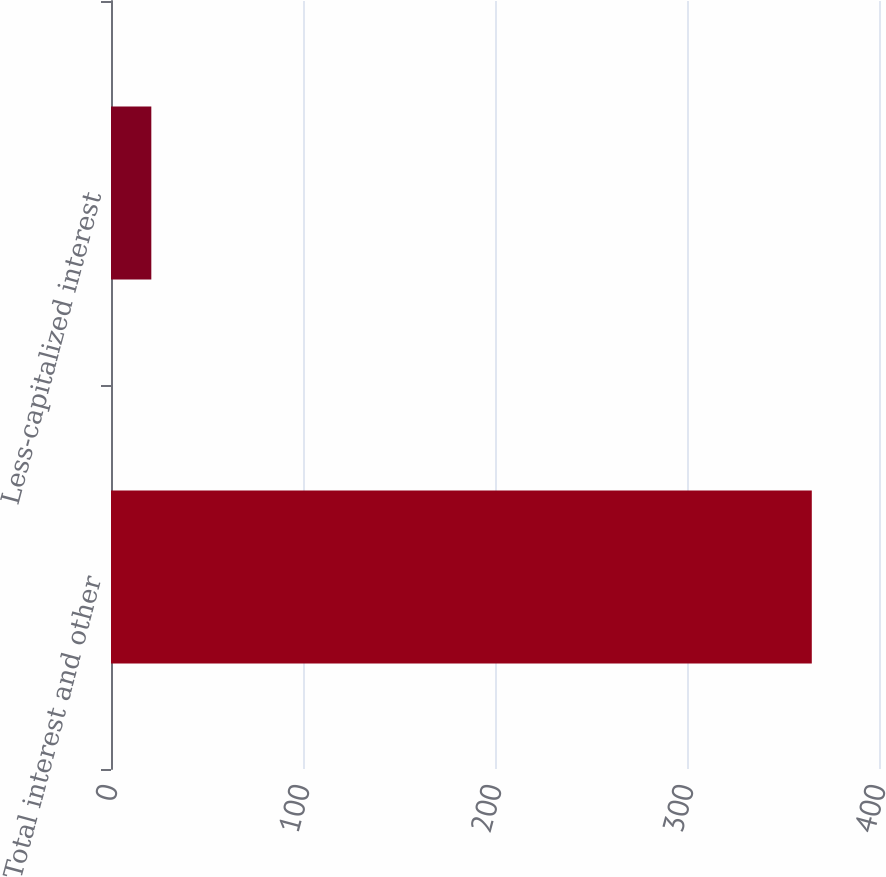Convert chart. <chart><loc_0><loc_0><loc_500><loc_500><bar_chart><fcel>Total interest and other<fcel>Less-capitalized interest<nl><fcel>365<fcel>21<nl></chart> 